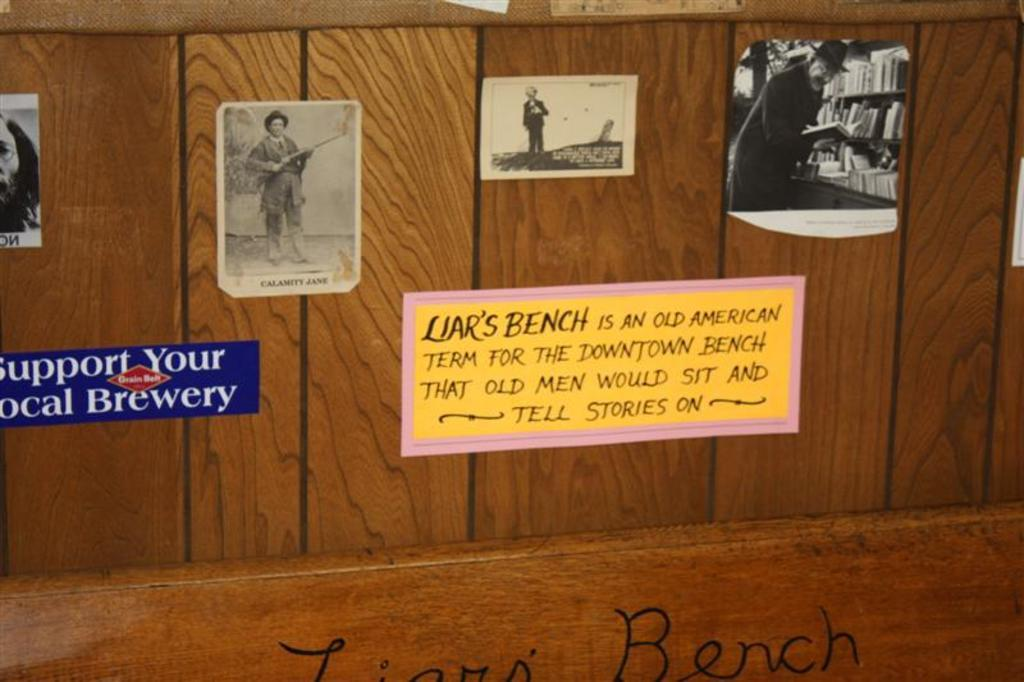Provide a one-sentence caption for the provided image. Wooden planks with various pictures attached including a sign that reads "support you local brewery". 